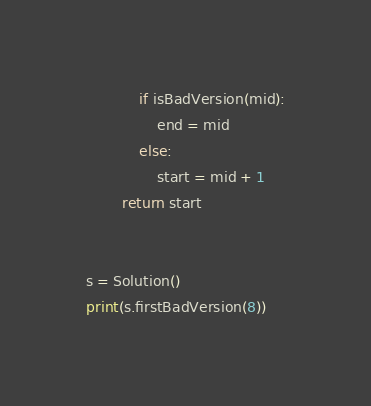<code> <loc_0><loc_0><loc_500><loc_500><_Python_>            if isBadVersion(mid):
                end = mid
            else:
                start = mid + 1
        return start


s = Solution()
print(s.firstBadVersion(8))
</code> 